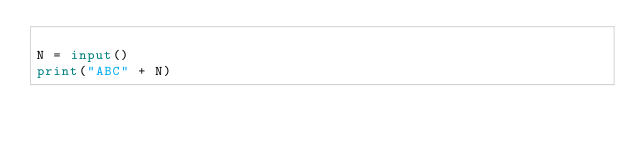<code> <loc_0><loc_0><loc_500><loc_500><_Python_>
N = input()
print("ABC" + N)
</code> 